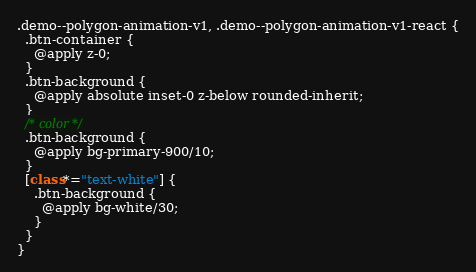Convert code to text. <code><loc_0><loc_0><loc_500><loc_500><_CSS_>
.demo--polygon-animation-v1, .demo--polygon-animation-v1-react {
  .btn-container {
    @apply z-0;
  }
  .btn-background {
    @apply absolute inset-0 z-below rounded-inherit;
  }
  /* color */
  .btn-background {
    @apply bg-primary-900/10;
  }
  [class*="text-white"] {
    .btn-background {
      @apply bg-white/30;
    }
  }
}
</code> 